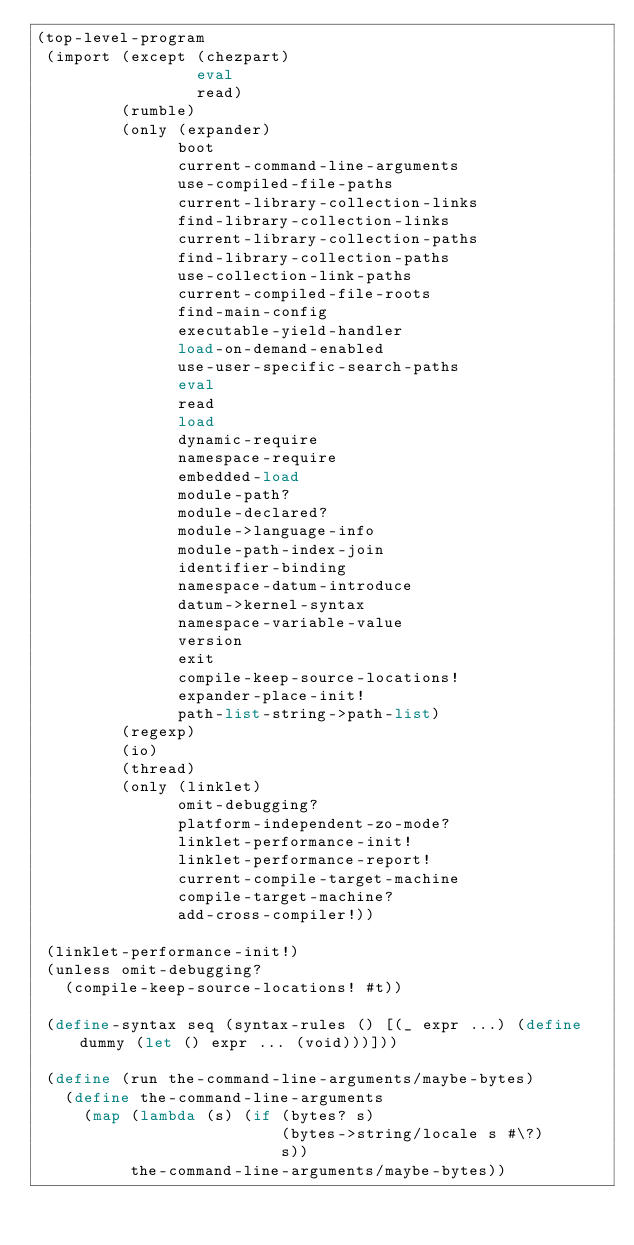<code> <loc_0><loc_0><loc_500><loc_500><_Scheme_>(top-level-program
 (import (except (chezpart)
                 eval
                 read)
         (rumble)
         (only (expander)
               boot
               current-command-line-arguments
               use-compiled-file-paths
               current-library-collection-links
               find-library-collection-links
               current-library-collection-paths
               find-library-collection-paths
               use-collection-link-paths
               current-compiled-file-roots
               find-main-config
               executable-yield-handler
               load-on-demand-enabled
               use-user-specific-search-paths
               eval
               read
               load
               dynamic-require
               namespace-require
               embedded-load
               module-path?
               module-declared?
               module->language-info
               module-path-index-join
               identifier-binding
               namespace-datum-introduce
               datum->kernel-syntax
               namespace-variable-value
               version
               exit
               compile-keep-source-locations!
               expander-place-init!
               path-list-string->path-list)
         (regexp)
         (io)
         (thread)
         (only (linklet)
               omit-debugging?
               platform-independent-zo-mode?
               linklet-performance-init!
               linklet-performance-report!
               current-compile-target-machine
               compile-target-machine?
               add-cross-compiler!))

 (linklet-performance-init!)
 (unless omit-debugging?
   (compile-keep-source-locations! #t))

 (define-syntax seq (syntax-rules () [(_ expr ...) (define dummy (let () expr ... (void)))]))

 (define (run the-command-line-arguments/maybe-bytes)
   (define the-command-line-arguments
     (map (lambda (s) (if (bytes? s)
                          (bytes->string/locale s #\?)
                          s))
          the-command-line-arguments/maybe-bytes))</code> 